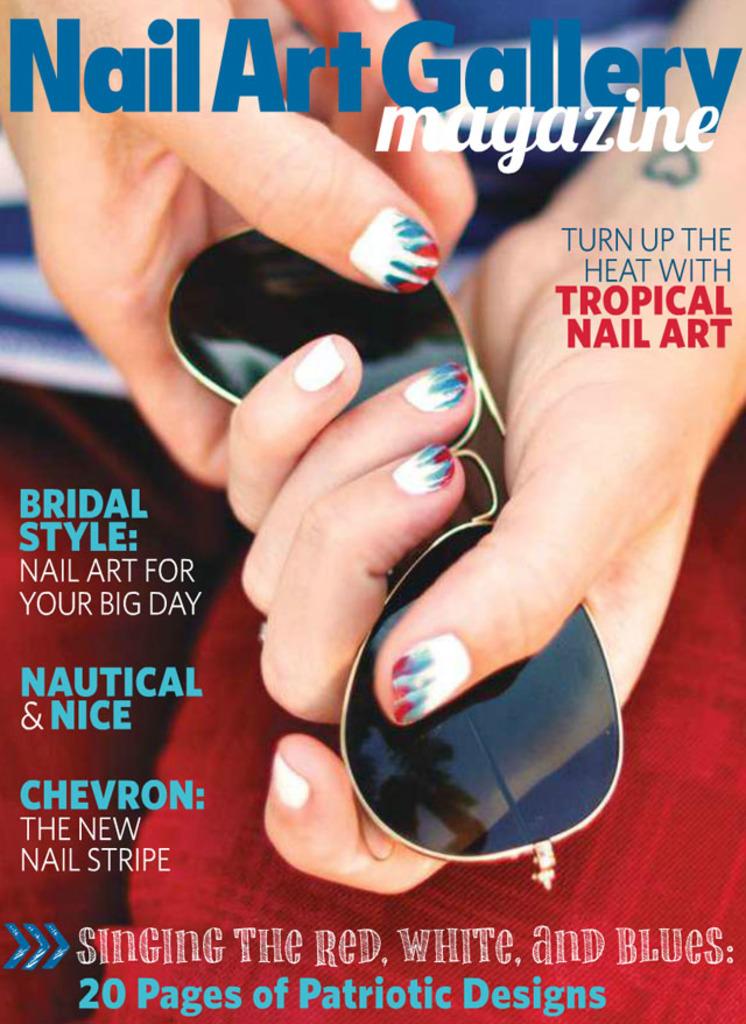What is the name of this magazine?
Your answer should be very brief. Nail art gallery. What is the lady in the front page of the magazine holding?
Keep it short and to the point. Answering does not require reading text in the image. 